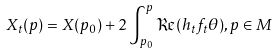<formula> <loc_0><loc_0><loc_500><loc_500>X _ { t } ( p ) = X ( p _ { 0 } ) + 2 \int _ { p _ { 0 } } ^ { p } \Re ( h _ { t } f _ { t } \theta ) , p \in M</formula> 